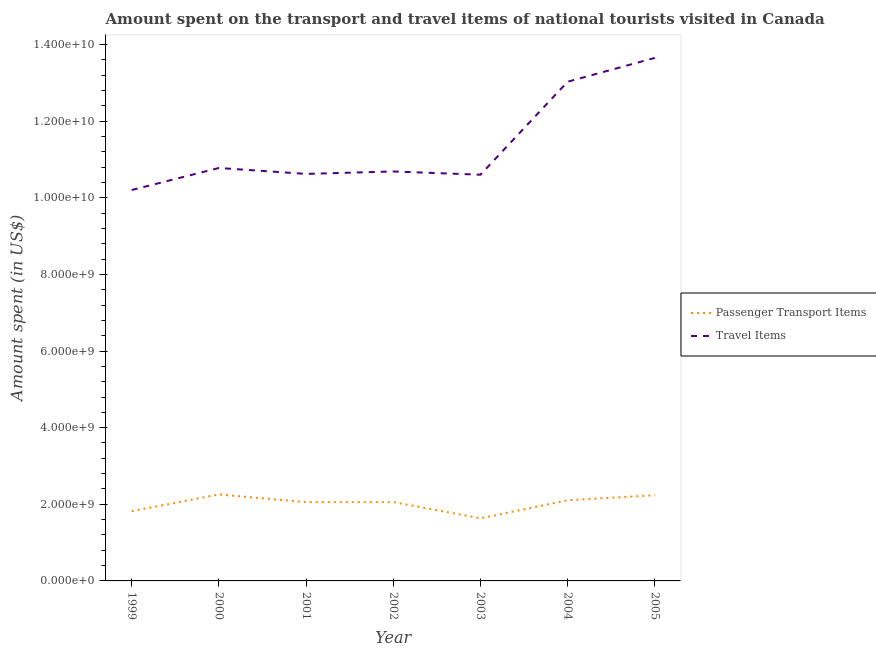Is the number of lines equal to the number of legend labels?
Give a very brief answer. Yes. What is the amount spent in travel items in 2003?
Make the answer very short. 1.06e+1. Across all years, what is the maximum amount spent in travel items?
Your answer should be very brief. 1.37e+1. Across all years, what is the minimum amount spent on passenger transport items?
Provide a succinct answer. 1.63e+09. In which year was the amount spent on passenger transport items maximum?
Your response must be concise. 2000. What is the total amount spent in travel items in the graph?
Offer a terse response. 7.96e+1. What is the difference between the amount spent on passenger transport items in 2003 and that in 2004?
Give a very brief answer. -4.72e+08. What is the difference between the amount spent in travel items in 2003 and the amount spent on passenger transport items in 2005?
Your answer should be compact. 8.37e+09. What is the average amount spent on passenger transport items per year?
Your response must be concise. 2.02e+09. In the year 2000, what is the difference between the amount spent on passenger transport items and amount spent in travel items?
Ensure brevity in your answer.  -8.52e+09. In how many years, is the amount spent on passenger transport items greater than 8800000000 US$?
Offer a very short reply. 0. What is the ratio of the amount spent on passenger transport items in 1999 to that in 2000?
Your answer should be compact. 0.81. What is the difference between the highest and the second highest amount spent on passenger transport items?
Make the answer very short. 2.10e+07. What is the difference between the highest and the lowest amount spent on passenger transport items?
Your answer should be compact. 6.23e+08. In how many years, is the amount spent in travel items greater than the average amount spent in travel items taken over all years?
Provide a succinct answer. 2. Is the sum of the amount spent in travel items in 2000 and 2001 greater than the maximum amount spent on passenger transport items across all years?
Your response must be concise. Yes. Is the amount spent on passenger transport items strictly less than the amount spent in travel items over the years?
Offer a very short reply. Yes. How many years are there in the graph?
Make the answer very short. 7. Are the values on the major ticks of Y-axis written in scientific E-notation?
Offer a terse response. Yes. Does the graph contain grids?
Make the answer very short. No. Where does the legend appear in the graph?
Your response must be concise. Center right. What is the title of the graph?
Provide a succinct answer. Amount spent on the transport and travel items of national tourists visited in Canada. What is the label or title of the Y-axis?
Your answer should be compact. Amount spent (in US$). What is the Amount spent (in US$) of Passenger Transport Items in 1999?
Give a very brief answer. 1.82e+09. What is the Amount spent (in US$) in Travel Items in 1999?
Offer a very short reply. 1.02e+1. What is the Amount spent (in US$) in Passenger Transport Items in 2000?
Your response must be concise. 2.26e+09. What is the Amount spent (in US$) of Travel Items in 2000?
Offer a terse response. 1.08e+1. What is the Amount spent (in US$) in Passenger Transport Items in 2001?
Your answer should be very brief. 2.06e+09. What is the Amount spent (in US$) of Travel Items in 2001?
Provide a short and direct response. 1.06e+1. What is the Amount spent (in US$) in Passenger Transport Items in 2002?
Your answer should be very brief. 2.06e+09. What is the Amount spent (in US$) of Travel Items in 2002?
Provide a succinct answer. 1.07e+1. What is the Amount spent (in US$) in Passenger Transport Items in 2003?
Offer a very short reply. 1.63e+09. What is the Amount spent (in US$) in Travel Items in 2003?
Make the answer very short. 1.06e+1. What is the Amount spent (in US$) in Passenger Transport Items in 2004?
Make the answer very short. 2.11e+09. What is the Amount spent (in US$) of Travel Items in 2004?
Ensure brevity in your answer.  1.30e+1. What is the Amount spent (in US$) in Passenger Transport Items in 2005?
Ensure brevity in your answer.  2.24e+09. What is the Amount spent (in US$) in Travel Items in 2005?
Provide a short and direct response. 1.37e+1. Across all years, what is the maximum Amount spent (in US$) of Passenger Transport Items?
Offer a terse response. 2.26e+09. Across all years, what is the maximum Amount spent (in US$) of Travel Items?
Give a very brief answer. 1.37e+1. Across all years, what is the minimum Amount spent (in US$) in Passenger Transport Items?
Offer a very short reply. 1.63e+09. Across all years, what is the minimum Amount spent (in US$) in Travel Items?
Your response must be concise. 1.02e+1. What is the total Amount spent (in US$) in Passenger Transport Items in the graph?
Offer a very short reply. 1.42e+1. What is the total Amount spent (in US$) of Travel Items in the graph?
Provide a short and direct response. 7.96e+1. What is the difference between the Amount spent (in US$) of Passenger Transport Items in 1999 and that in 2000?
Your answer should be very brief. -4.36e+08. What is the difference between the Amount spent (in US$) in Travel Items in 1999 and that in 2000?
Your response must be concise. -5.75e+08. What is the difference between the Amount spent (in US$) of Passenger Transport Items in 1999 and that in 2001?
Give a very brief answer. -2.36e+08. What is the difference between the Amount spent (in US$) in Travel Items in 1999 and that in 2001?
Your response must be concise. -4.20e+08. What is the difference between the Amount spent (in US$) of Passenger Transport Items in 1999 and that in 2002?
Your answer should be very brief. -2.36e+08. What is the difference between the Amount spent (in US$) in Travel Items in 1999 and that in 2002?
Provide a short and direct response. -4.84e+08. What is the difference between the Amount spent (in US$) of Passenger Transport Items in 1999 and that in 2003?
Provide a succinct answer. 1.87e+08. What is the difference between the Amount spent (in US$) of Travel Items in 1999 and that in 2003?
Offer a very short reply. -3.99e+08. What is the difference between the Amount spent (in US$) of Passenger Transport Items in 1999 and that in 2004?
Make the answer very short. -2.85e+08. What is the difference between the Amount spent (in US$) in Travel Items in 1999 and that in 2004?
Provide a succinct answer. -2.83e+09. What is the difference between the Amount spent (in US$) of Passenger Transport Items in 1999 and that in 2005?
Your answer should be very brief. -4.15e+08. What is the difference between the Amount spent (in US$) of Travel Items in 1999 and that in 2005?
Give a very brief answer. -3.45e+09. What is the difference between the Amount spent (in US$) in Passenger Transport Items in 2000 and that in 2001?
Offer a very short reply. 2.00e+08. What is the difference between the Amount spent (in US$) in Travel Items in 2000 and that in 2001?
Your answer should be very brief. 1.55e+08. What is the difference between the Amount spent (in US$) in Passenger Transport Items in 2000 and that in 2002?
Offer a terse response. 2.00e+08. What is the difference between the Amount spent (in US$) of Travel Items in 2000 and that in 2002?
Your response must be concise. 9.10e+07. What is the difference between the Amount spent (in US$) in Passenger Transport Items in 2000 and that in 2003?
Offer a terse response. 6.23e+08. What is the difference between the Amount spent (in US$) in Travel Items in 2000 and that in 2003?
Make the answer very short. 1.76e+08. What is the difference between the Amount spent (in US$) of Passenger Transport Items in 2000 and that in 2004?
Provide a short and direct response. 1.51e+08. What is the difference between the Amount spent (in US$) in Travel Items in 2000 and that in 2004?
Your answer should be compact. -2.25e+09. What is the difference between the Amount spent (in US$) in Passenger Transport Items in 2000 and that in 2005?
Your answer should be very brief. 2.10e+07. What is the difference between the Amount spent (in US$) of Travel Items in 2000 and that in 2005?
Your answer should be very brief. -2.87e+09. What is the difference between the Amount spent (in US$) in Travel Items in 2001 and that in 2002?
Provide a short and direct response. -6.40e+07. What is the difference between the Amount spent (in US$) of Passenger Transport Items in 2001 and that in 2003?
Make the answer very short. 4.23e+08. What is the difference between the Amount spent (in US$) in Travel Items in 2001 and that in 2003?
Offer a terse response. 2.10e+07. What is the difference between the Amount spent (in US$) of Passenger Transport Items in 2001 and that in 2004?
Offer a very short reply. -4.90e+07. What is the difference between the Amount spent (in US$) in Travel Items in 2001 and that in 2004?
Give a very brief answer. -2.41e+09. What is the difference between the Amount spent (in US$) in Passenger Transport Items in 2001 and that in 2005?
Your answer should be very brief. -1.79e+08. What is the difference between the Amount spent (in US$) of Travel Items in 2001 and that in 2005?
Your answer should be compact. -3.03e+09. What is the difference between the Amount spent (in US$) of Passenger Transport Items in 2002 and that in 2003?
Keep it short and to the point. 4.23e+08. What is the difference between the Amount spent (in US$) in Travel Items in 2002 and that in 2003?
Provide a succinct answer. 8.50e+07. What is the difference between the Amount spent (in US$) of Passenger Transport Items in 2002 and that in 2004?
Your response must be concise. -4.90e+07. What is the difference between the Amount spent (in US$) in Travel Items in 2002 and that in 2004?
Your response must be concise. -2.34e+09. What is the difference between the Amount spent (in US$) in Passenger Transport Items in 2002 and that in 2005?
Offer a very short reply. -1.79e+08. What is the difference between the Amount spent (in US$) in Travel Items in 2002 and that in 2005?
Your answer should be compact. -2.96e+09. What is the difference between the Amount spent (in US$) of Passenger Transport Items in 2003 and that in 2004?
Make the answer very short. -4.72e+08. What is the difference between the Amount spent (in US$) in Travel Items in 2003 and that in 2004?
Offer a very short reply. -2.43e+09. What is the difference between the Amount spent (in US$) in Passenger Transport Items in 2003 and that in 2005?
Provide a succinct answer. -6.02e+08. What is the difference between the Amount spent (in US$) of Travel Items in 2003 and that in 2005?
Provide a succinct answer. -3.05e+09. What is the difference between the Amount spent (in US$) of Passenger Transport Items in 2004 and that in 2005?
Offer a very short reply. -1.30e+08. What is the difference between the Amount spent (in US$) of Travel Items in 2004 and that in 2005?
Offer a terse response. -6.22e+08. What is the difference between the Amount spent (in US$) of Passenger Transport Items in 1999 and the Amount spent (in US$) of Travel Items in 2000?
Offer a terse response. -8.96e+09. What is the difference between the Amount spent (in US$) of Passenger Transport Items in 1999 and the Amount spent (in US$) of Travel Items in 2001?
Ensure brevity in your answer.  -8.80e+09. What is the difference between the Amount spent (in US$) in Passenger Transport Items in 1999 and the Amount spent (in US$) in Travel Items in 2002?
Ensure brevity in your answer.  -8.87e+09. What is the difference between the Amount spent (in US$) of Passenger Transport Items in 1999 and the Amount spent (in US$) of Travel Items in 2003?
Give a very brief answer. -8.78e+09. What is the difference between the Amount spent (in US$) in Passenger Transport Items in 1999 and the Amount spent (in US$) in Travel Items in 2004?
Make the answer very short. -1.12e+1. What is the difference between the Amount spent (in US$) in Passenger Transport Items in 1999 and the Amount spent (in US$) in Travel Items in 2005?
Provide a short and direct response. -1.18e+1. What is the difference between the Amount spent (in US$) of Passenger Transport Items in 2000 and the Amount spent (in US$) of Travel Items in 2001?
Your answer should be compact. -8.37e+09. What is the difference between the Amount spent (in US$) of Passenger Transport Items in 2000 and the Amount spent (in US$) of Travel Items in 2002?
Your answer should be compact. -8.43e+09. What is the difference between the Amount spent (in US$) in Passenger Transport Items in 2000 and the Amount spent (in US$) in Travel Items in 2003?
Offer a very short reply. -8.34e+09. What is the difference between the Amount spent (in US$) in Passenger Transport Items in 2000 and the Amount spent (in US$) in Travel Items in 2004?
Provide a short and direct response. -1.08e+1. What is the difference between the Amount spent (in US$) of Passenger Transport Items in 2000 and the Amount spent (in US$) of Travel Items in 2005?
Your answer should be compact. -1.14e+1. What is the difference between the Amount spent (in US$) of Passenger Transport Items in 2001 and the Amount spent (in US$) of Travel Items in 2002?
Your answer should be very brief. -8.63e+09. What is the difference between the Amount spent (in US$) of Passenger Transport Items in 2001 and the Amount spent (in US$) of Travel Items in 2003?
Your response must be concise. -8.54e+09. What is the difference between the Amount spent (in US$) of Passenger Transport Items in 2001 and the Amount spent (in US$) of Travel Items in 2004?
Provide a succinct answer. -1.10e+1. What is the difference between the Amount spent (in US$) of Passenger Transport Items in 2001 and the Amount spent (in US$) of Travel Items in 2005?
Your answer should be compact. -1.16e+1. What is the difference between the Amount spent (in US$) of Passenger Transport Items in 2002 and the Amount spent (in US$) of Travel Items in 2003?
Your answer should be compact. -8.54e+09. What is the difference between the Amount spent (in US$) in Passenger Transport Items in 2002 and the Amount spent (in US$) in Travel Items in 2004?
Your answer should be compact. -1.10e+1. What is the difference between the Amount spent (in US$) in Passenger Transport Items in 2002 and the Amount spent (in US$) in Travel Items in 2005?
Keep it short and to the point. -1.16e+1. What is the difference between the Amount spent (in US$) in Passenger Transport Items in 2003 and the Amount spent (in US$) in Travel Items in 2004?
Make the answer very short. -1.14e+1. What is the difference between the Amount spent (in US$) of Passenger Transport Items in 2003 and the Amount spent (in US$) of Travel Items in 2005?
Make the answer very short. -1.20e+1. What is the difference between the Amount spent (in US$) in Passenger Transport Items in 2004 and the Amount spent (in US$) in Travel Items in 2005?
Your response must be concise. -1.15e+1. What is the average Amount spent (in US$) of Passenger Transport Items per year?
Offer a terse response. 2.02e+09. What is the average Amount spent (in US$) in Travel Items per year?
Your response must be concise. 1.14e+1. In the year 1999, what is the difference between the Amount spent (in US$) of Passenger Transport Items and Amount spent (in US$) of Travel Items?
Your answer should be compact. -8.38e+09. In the year 2000, what is the difference between the Amount spent (in US$) in Passenger Transport Items and Amount spent (in US$) in Travel Items?
Ensure brevity in your answer.  -8.52e+09. In the year 2001, what is the difference between the Amount spent (in US$) in Passenger Transport Items and Amount spent (in US$) in Travel Items?
Make the answer very short. -8.57e+09. In the year 2002, what is the difference between the Amount spent (in US$) of Passenger Transport Items and Amount spent (in US$) of Travel Items?
Ensure brevity in your answer.  -8.63e+09. In the year 2003, what is the difference between the Amount spent (in US$) in Passenger Transport Items and Amount spent (in US$) in Travel Items?
Your answer should be very brief. -8.97e+09. In the year 2004, what is the difference between the Amount spent (in US$) in Passenger Transport Items and Amount spent (in US$) in Travel Items?
Ensure brevity in your answer.  -1.09e+1. In the year 2005, what is the difference between the Amount spent (in US$) in Passenger Transport Items and Amount spent (in US$) in Travel Items?
Offer a terse response. -1.14e+1. What is the ratio of the Amount spent (in US$) in Passenger Transport Items in 1999 to that in 2000?
Keep it short and to the point. 0.81. What is the ratio of the Amount spent (in US$) in Travel Items in 1999 to that in 2000?
Provide a succinct answer. 0.95. What is the ratio of the Amount spent (in US$) of Passenger Transport Items in 1999 to that in 2001?
Your answer should be very brief. 0.89. What is the ratio of the Amount spent (in US$) in Travel Items in 1999 to that in 2001?
Make the answer very short. 0.96. What is the ratio of the Amount spent (in US$) of Passenger Transport Items in 1999 to that in 2002?
Make the answer very short. 0.89. What is the ratio of the Amount spent (in US$) of Travel Items in 1999 to that in 2002?
Provide a short and direct response. 0.95. What is the ratio of the Amount spent (in US$) of Passenger Transport Items in 1999 to that in 2003?
Offer a very short reply. 1.11. What is the ratio of the Amount spent (in US$) of Travel Items in 1999 to that in 2003?
Provide a short and direct response. 0.96. What is the ratio of the Amount spent (in US$) in Passenger Transport Items in 1999 to that in 2004?
Provide a succinct answer. 0.86. What is the ratio of the Amount spent (in US$) of Travel Items in 1999 to that in 2004?
Your response must be concise. 0.78. What is the ratio of the Amount spent (in US$) in Passenger Transport Items in 1999 to that in 2005?
Your answer should be compact. 0.81. What is the ratio of the Amount spent (in US$) of Travel Items in 1999 to that in 2005?
Offer a very short reply. 0.75. What is the ratio of the Amount spent (in US$) of Passenger Transport Items in 2000 to that in 2001?
Provide a short and direct response. 1.1. What is the ratio of the Amount spent (in US$) in Travel Items in 2000 to that in 2001?
Your answer should be compact. 1.01. What is the ratio of the Amount spent (in US$) in Passenger Transport Items in 2000 to that in 2002?
Give a very brief answer. 1.1. What is the ratio of the Amount spent (in US$) in Travel Items in 2000 to that in 2002?
Provide a short and direct response. 1.01. What is the ratio of the Amount spent (in US$) in Passenger Transport Items in 2000 to that in 2003?
Ensure brevity in your answer.  1.38. What is the ratio of the Amount spent (in US$) of Travel Items in 2000 to that in 2003?
Offer a very short reply. 1.02. What is the ratio of the Amount spent (in US$) of Passenger Transport Items in 2000 to that in 2004?
Give a very brief answer. 1.07. What is the ratio of the Amount spent (in US$) of Travel Items in 2000 to that in 2004?
Offer a terse response. 0.83. What is the ratio of the Amount spent (in US$) in Passenger Transport Items in 2000 to that in 2005?
Give a very brief answer. 1.01. What is the ratio of the Amount spent (in US$) of Travel Items in 2000 to that in 2005?
Provide a succinct answer. 0.79. What is the ratio of the Amount spent (in US$) of Travel Items in 2001 to that in 2002?
Offer a very short reply. 0.99. What is the ratio of the Amount spent (in US$) of Passenger Transport Items in 2001 to that in 2003?
Your response must be concise. 1.26. What is the ratio of the Amount spent (in US$) in Travel Items in 2001 to that in 2003?
Make the answer very short. 1. What is the ratio of the Amount spent (in US$) of Passenger Transport Items in 2001 to that in 2004?
Your answer should be compact. 0.98. What is the ratio of the Amount spent (in US$) in Travel Items in 2001 to that in 2004?
Your answer should be very brief. 0.82. What is the ratio of the Amount spent (in US$) in Passenger Transport Items in 2001 to that in 2005?
Offer a very short reply. 0.92. What is the ratio of the Amount spent (in US$) of Travel Items in 2001 to that in 2005?
Your answer should be compact. 0.78. What is the ratio of the Amount spent (in US$) in Passenger Transport Items in 2002 to that in 2003?
Offer a terse response. 1.26. What is the ratio of the Amount spent (in US$) in Travel Items in 2002 to that in 2003?
Provide a succinct answer. 1.01. What is the ratio of the Amount spent (in US$) in Passenger Transport Items in 2002 to that in 2004?
Your response must be concise. 0.98. What is the ratio of the Amount spent (in US$) in Travel Items in 2002 to that in 2004?
Offer a terse response. 0.82. What is the ratio of the Amount spent (in US$) of Passenger Transport Items in 2002 to that in 2005?
Make the answer very short. 0.92. What is the ratio of the Amount spent (in US$) in Travel Items in 2002 to that in 2005?
Provide a short and direct response. 0.78. What is the ratio of the Amount spent (in US$) in Passenger Transport Items in 2003 to that in 2004?
Provide a succinct answer. 0.78. What is the ratio of the Amount spent (in US$) in Travel Items in 2003 to that in 2004?
Offer a very short reply. 0.81. What is the ratio of the Amount spent (in US$) of Passenger Transport Items in 2003 to that in 2005?
Ensure brevity in your answer.  0.73. What is the ratio of the Amount spent (in US$) in Travel Items in 2003 to that in 2005?
Your response must be concise. 0.78. What is the ratio of the Amount spent (in US$) of Passenger Transport Items in 2004 to that in 2005?
Provide a succinct answer. 0.94. What is the ratio of the Amount spent (in US$) in Travel Items in 2004 to that in 2005?
Ensure brevity in your answer.  0.95. What is the difference between the highest and the second highest Amount spent (in US$) of Passenger Transport Items?
Ensure brevity in your answer.  2.10e+07. What is the difference between the highest and the second highest Amount spent (in US$) of Travel Items?
Give a very brief answer. 6.22e+08. What is the difference between the highest and the lowest Amount spent (in US$) in Passenger Transport Items?
Make the answer very short. 6.23e+08. What is the difference between the highest and the lowest Amount spent (in US$) of Travel Items?
Offer a very short reply. 3.45e+09. 